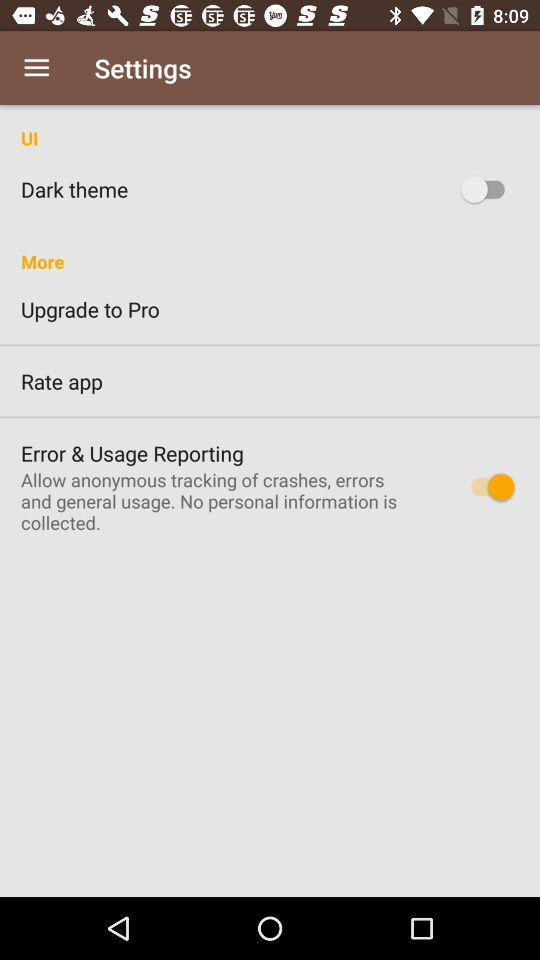What is the status of the dark theme setting? The status is off. 